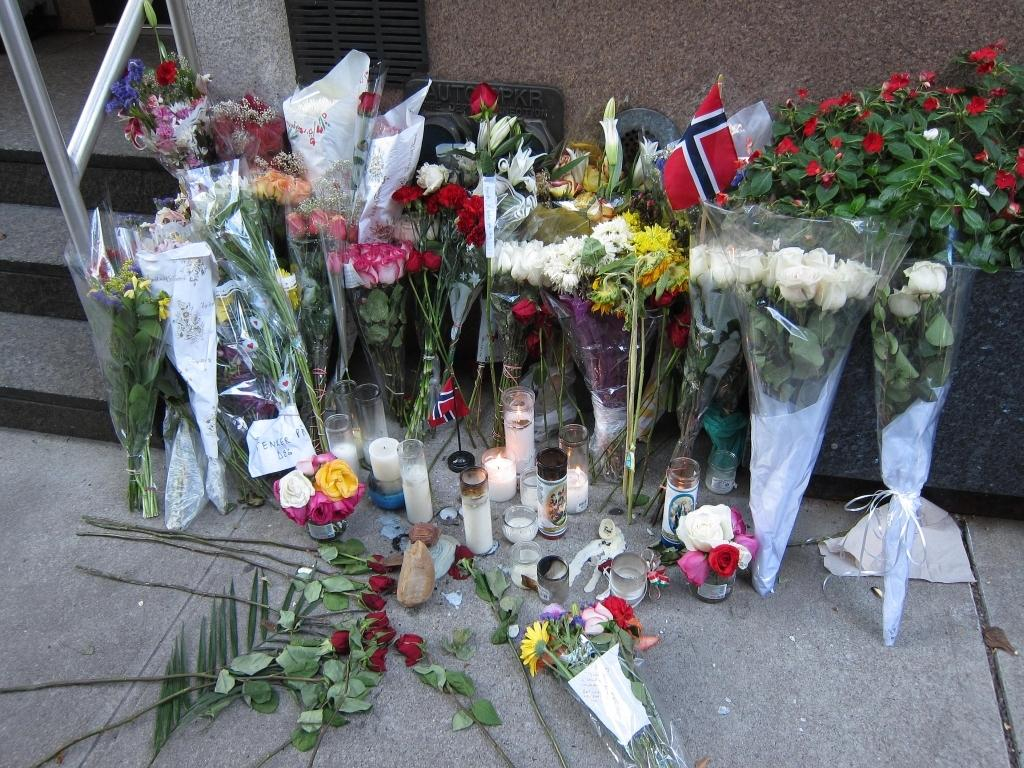What type of structure can be seen in the image? There are stairs and a wall visible in the image. What type of decorations are present in the image? There are bouquets and flowers in the image. What is the grade of the hill in the image? There is no hill present in the image; it features stairs and a wall. 